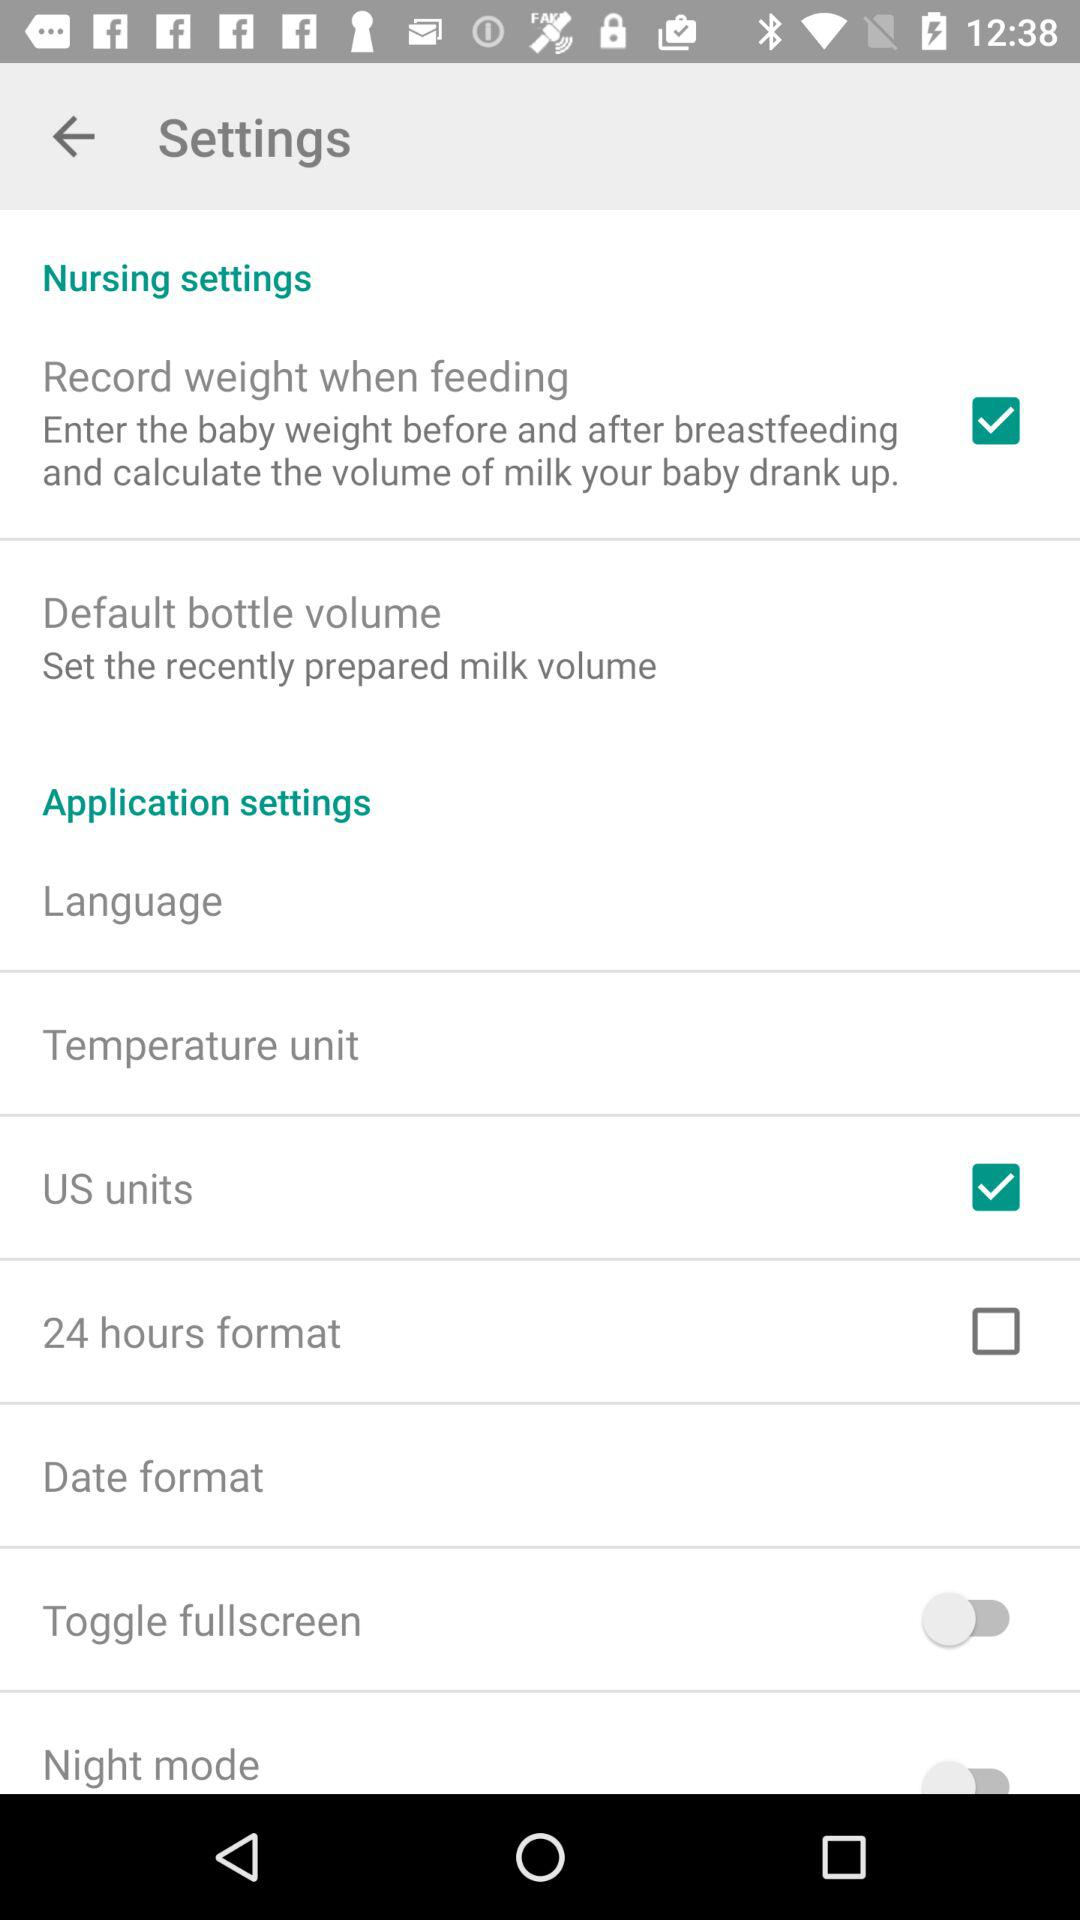What is the description given for the "Default bottle volume"? The description is "Set the recently prepared milk volume". 